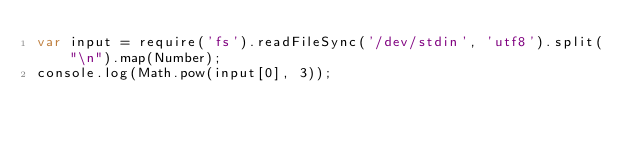<code> <loc_0><loc_0><loc_500><loc_500><_JavaScript_>var input = require('fs').readFileSync('/dev/stdin', 'utf8').split("\n").map(Number);
console.log(Math.pow(input[0], 3));</code> 